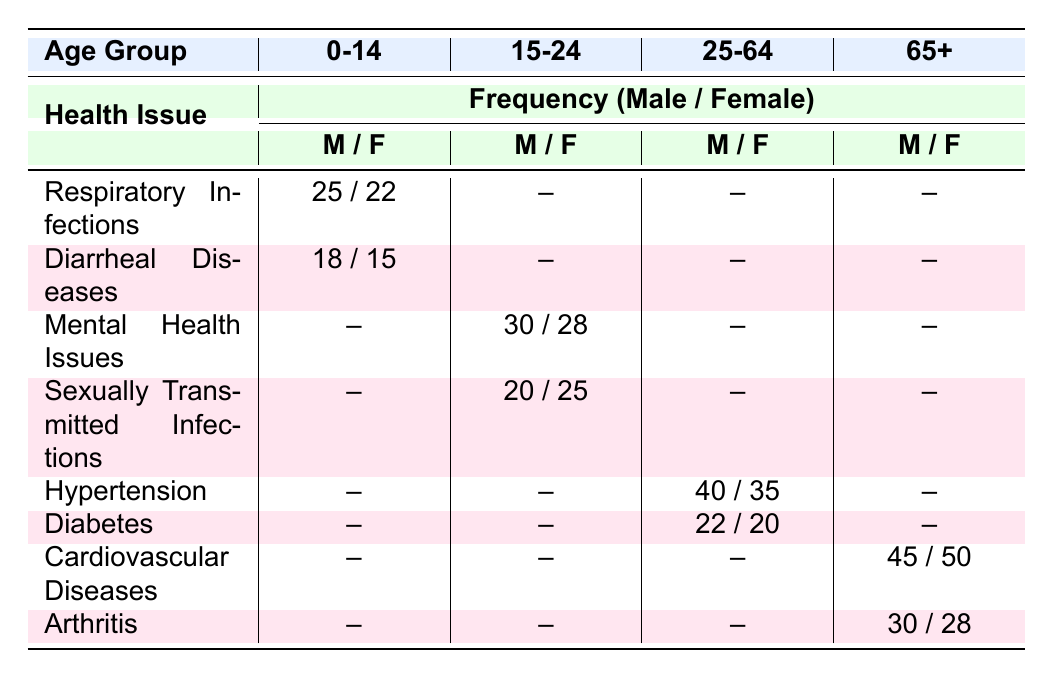What is the frequency of respiratory infections reported by females in the age group 0-14? According to the table, in the age group 0-14, the frequency of respiratory infections for females is mentioned as 22.
Answer: 22 Which health issue has the highest frequency reported by males aged 65 and older? The table shows that for males aged 65 and older, cardiovascular diseases have the highest frequency at 45 when compared to arthritis which is at 30.
Answer: Cardiovascular Diseases What is the total frequency of diarrheal diseases reported for the age group 0-14? The table indicates the frequency of diarrheal diseases for males as 18 and for females as 15. Adding these gives 18 + 15 = 33 for the total frequency in this age group.
Answer: 33 Is there a health issue reported for females aged 25-64? Checking the table, it shows that there are health issues reported for females in the 25-64 age group: hypertension and diabetes were recorded with frequencies of 35 and 20 respectively. Therefore, the answer is yes.
Answer: Yes What is the difference in frequency of hypertension reported between males and females in the age group 25-64? The frequency for males is 40 and for females is 35. The difference can be calculated as 40 - 35 = 5.
Answer: 5 Which health issue has a higher frequency: mental health issues among males aged 15-24 or sexually transmitted infections among females aged 15-24? For males aged 15-24, the frequency of mental health issues is 30, while for females aged 15-24, sexually transmitted infections have a frequency of 25. Comparing these shows that mental health issues are higher.
Answer: Mental Health Issues How many total health issues are reported for the age group 65 and older? The table lists two health issues for the age group 65 and older: cardiovascular diseases and arthritis, both with their respective frequencies. Hence, the total number of health issues is 2.
Answer: 2 What is the average frequency of health issues for females aged 0-14? The table shows that females in the 0-14 age group have respiratory infections at 22 and diarrheal diseases at 15. The average is calculated as (22 + 15) / 2 = 18.5.
Answer: 18.5 Is the frequency of diabetes higher for males or females in the age group 25-64? According to the table, males have a frequency of diabetes at 22 while females have a frequency of 20. Hence, the female frequency is lower than the male frequency.
Answer: No 